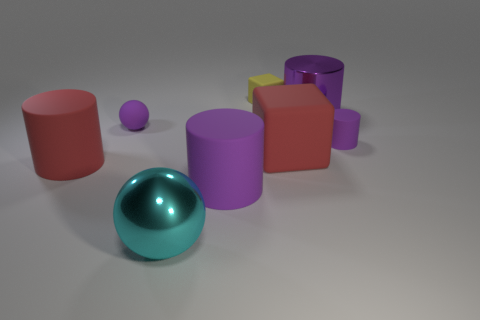Are there any cyan objects on the left side of the small matte block?
Keep it short and to the point. Yes. What size is the purple rubber object that is the same shape as the big cyan thing?
Offer a terse response. Small. Is the number of red matte cubes behind the small matte block the same as the number of large rubber objects behind the small purple rubber cylinder?
Give a very brief answer. Yes. How many things are there?
Give a very brief answer. 8. Are there more cyan shiny balls behind the cyan metallic thing than red things?
Make the answer very short. No. What is the red object that is to the right of the big sphere made of?
Provide a succinct answer. Rubber. What color is the other small thing that is the same shape as the cyan object?
Your response must be concise. Purple. How many small balls have the same color as the metal cylinder?
Your response must be concise. 1. Do the red object that is on the right side of the big sphere and the purple rubber cylinder that is left of the tiny yellow object have the same size?
Ensure brevity in your answer.  Yes. Do the purple matte sphere and the rubber object on the left side of the tiny purple ball have the same size?
Give a very brief answer. No. 